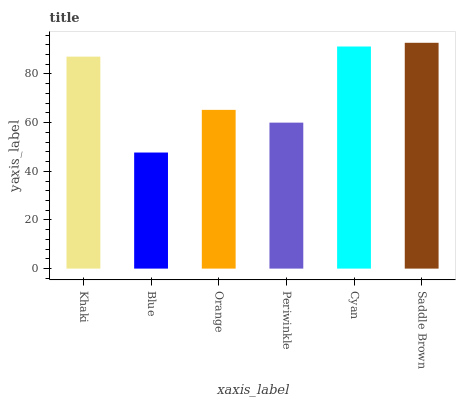Is Blue the minimum?
Answer yes or no. Yes. Is Saddle Brown the maximum?
Answer yes or no. Yes. Is Orange the minimum?
Answer yes or no. No. Is Orange the maximum?
Answer yes or no. No. Is Orange greater than Blue?
Answer yes or no. Yes. Is Blue less than Orange?
Answer yes or no. Yes. Is Blue greater than Orange?
Answer yes or no. No. Is Orange less than Blue?
Answer yes or no. No. Is Khaki the high median?
Answer yes or no. Yes. Is Orange the low median?
Answer yes or no. Yes. Is Saddle Brown the high median?
Answer yes or no. No. Is Blue the low median?
Answer yes or no. No. 